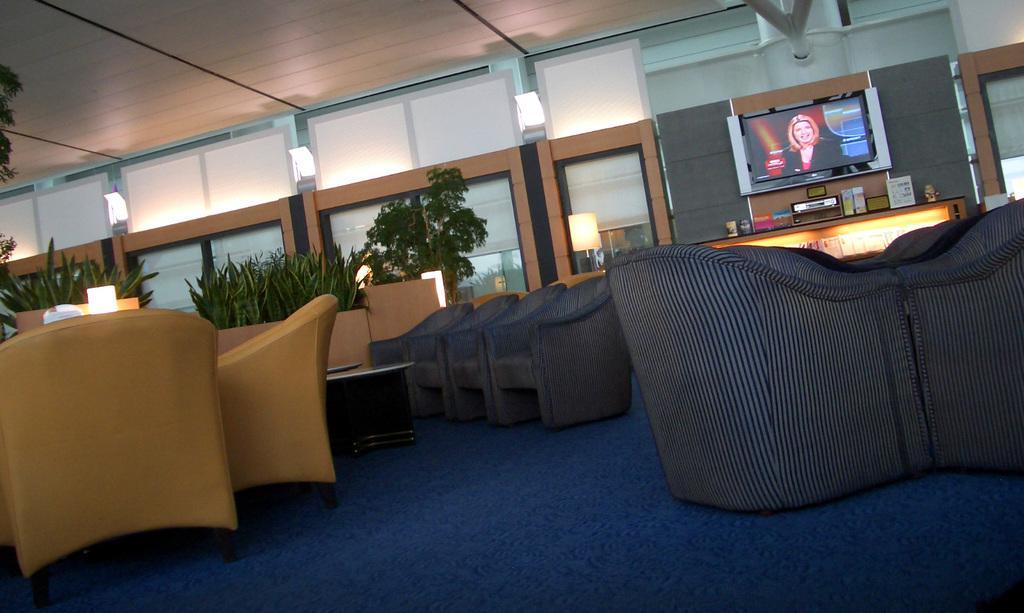Describe this image in one or two sentences. In this image I see the couches which are of cream and dark blue in color and I see the floor which is of blue in color. In the background I see the plants and I see a screen over here and I see the lights and the ceiling. 